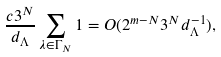Convert formula to latex. <formula><loc_0><loc_0><loc_500><loc_500>\frac { c 3 ^ { N } } { d _ { \Lambda } } \sum _ { \lambda \in \Gamma _ { N } } 1 = O ( 2 ^ { m - N } 3 ^ { N } d _ { \Lambda } ^ { - 1 } ) ,</formula> 